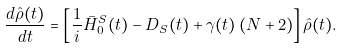Convert formula to latex. <formula><loc_0><loc_0><loc_500><loc_500>\frac { d \hat { \rho } ( t ) } { d t } = \left [ \frac { 1 } { i } \bar { H } _ { 0 } ^ { S } ( t ) - D _ { S } ( t ) + \gamma ( t ) \left ( N + 2 \right ) \right ] \hat { \rho } ( t ) .</formula> 